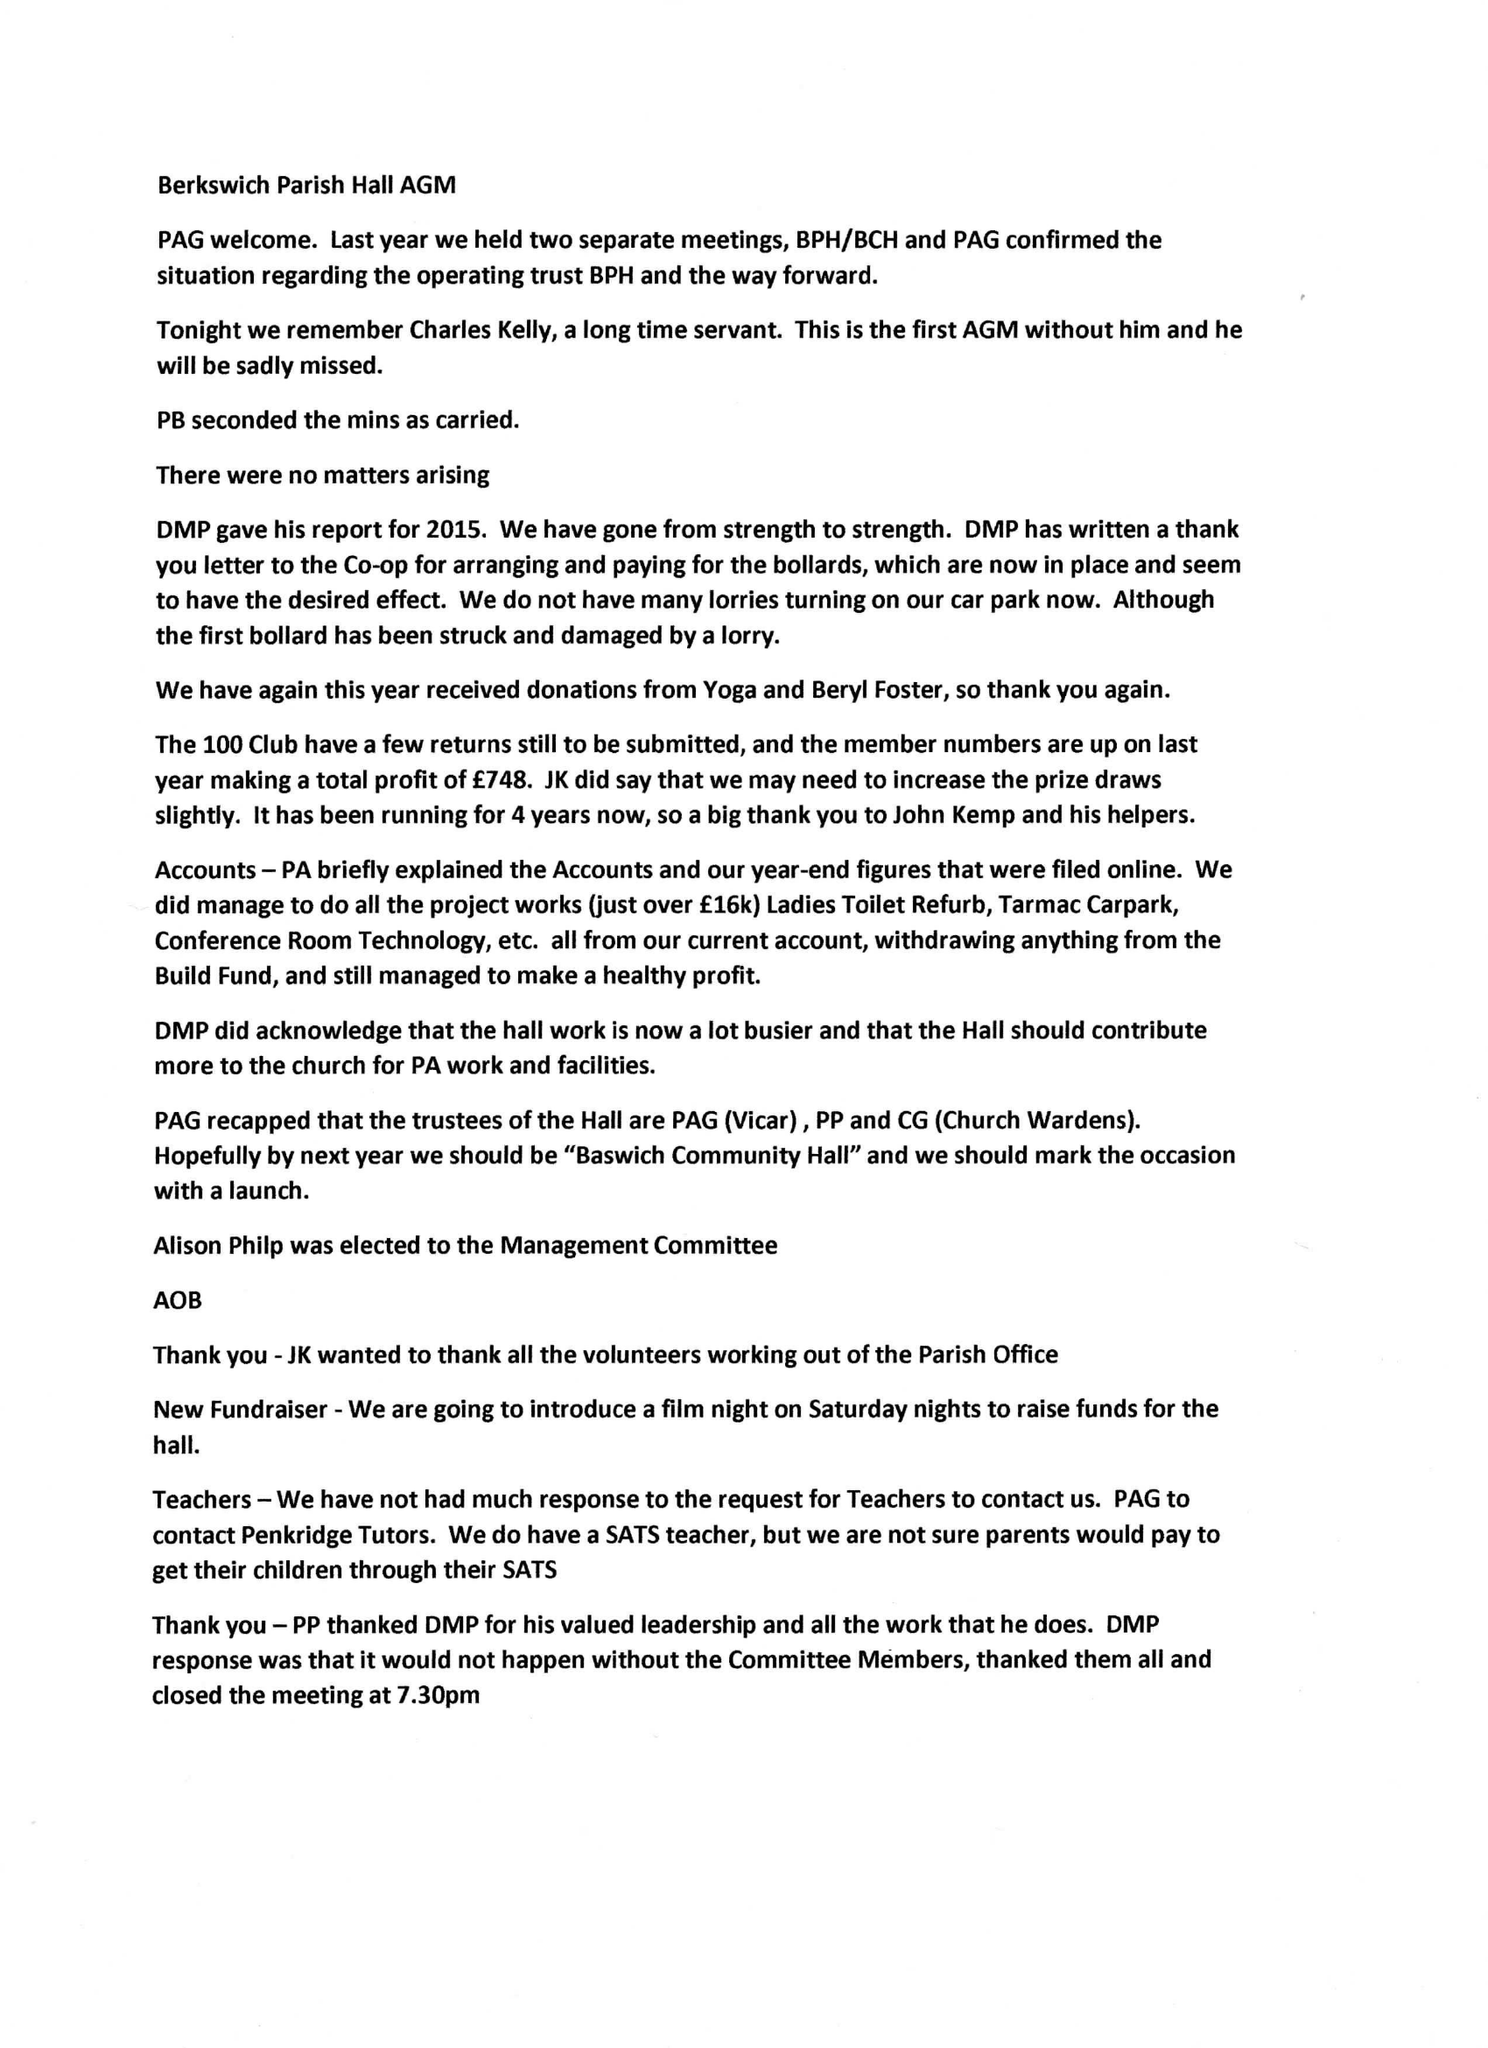What is the value for the charity_number?
Answer the question using a single word or phrase. 1133076 